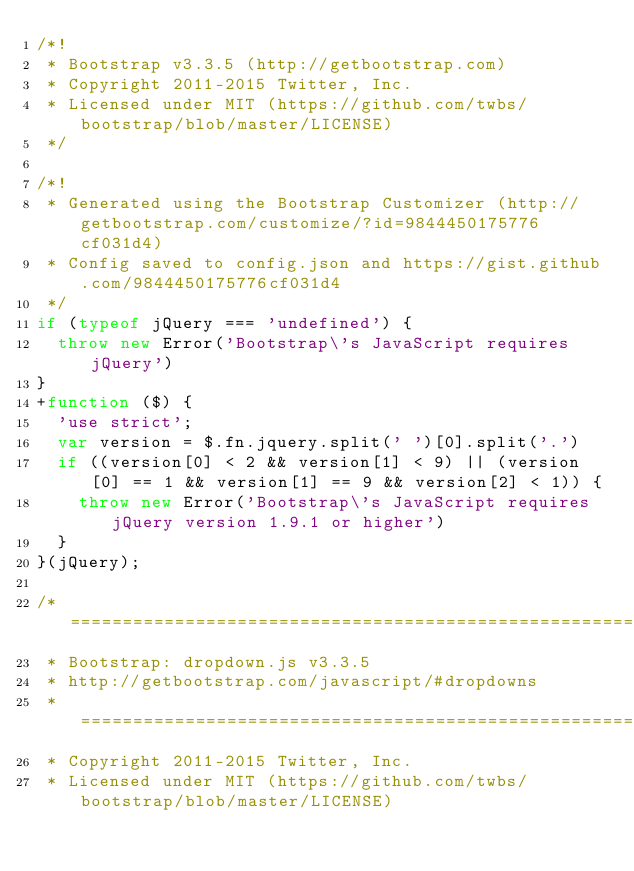Convert code to text. <code><loc_0><loc_0><loc_500><loc_500><_JavaScript_>/*!
 * Bootstrap v3.3.5 (http://getbootstrap.com)
 * Copyright 2011-2015 Twitter, Inc.
 * Licensed under MIT (https://github.com/twbs/bootstrap/blob/master/LICENSE)
 */

/*!
 * Generated using the Bootstrap Customizer (http://getbootstrap.com/customize/?id=9844450175776cf031d4)
 * Config saved to config.json and https://gist.github.com/9844450175776cf031d4
 */
if (typeof jQuery === 'undefined') {
  throw new Error('Bootstrap\'s JavaScript requires jQuery')
}
+function ($) {
  'use strict';
  var version = $.fn.jquery.split(' ')[0].split('.')
  if ((version[0] < 2 && version[1] < 9) || (version[0] == 1 && version[1] == 9 && version[2] < 1)) {
    throw new Error('Bootstrap\'s JavaScript requires jQuery version 1.9.1 or higher')
  }
}(jQuery);

/* ========================================================================
 * Bootstrap: dropdown.js v3.3.5
 * http://getbootstrap.com/javascript/#dropdowns
 * ========================================================================
 * Copyright 2011-2015 Twitter, Inc.
 * Licensed under MIT (https://github.com/twbs/bootstrap/blob/master/LICENSE)</code> 